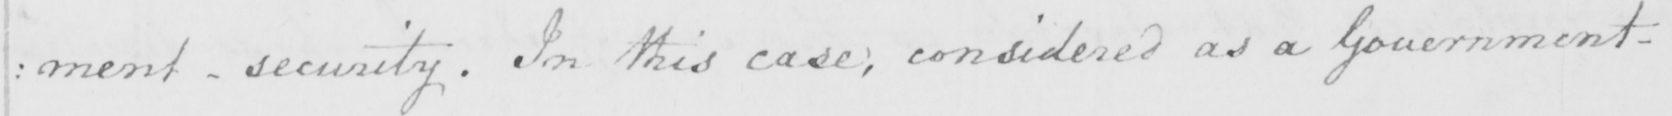What text is written in this handwritten line? : ment Security . In this case ; considered as a Government 